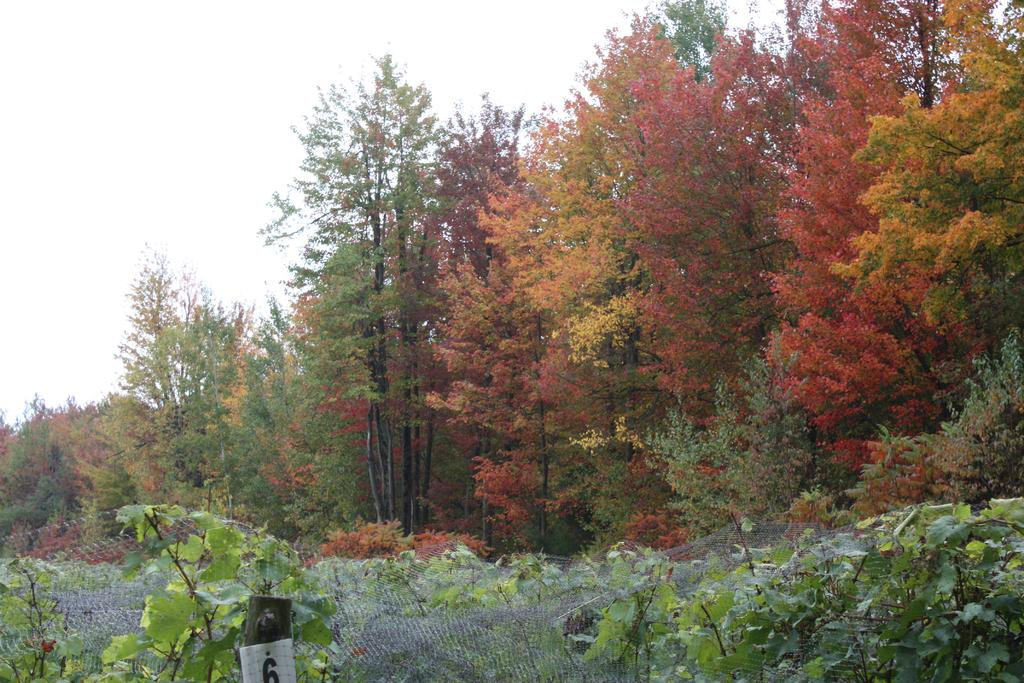What type of vegetation can be seen in the image? There are trees and plants in the image. What else is present in the image besides vegetation? There is a net in the image. What is visible at the top of the image? The sky is visible at the top of the image, and it is clear. What type of yoke is being used by the plants in the image? There is no yoke present in the image; it features trees, plants, and a net. What is the thing being offered by the trees in the image? There is no thing being offered by the trees in the image; they are simply standing in the image. 